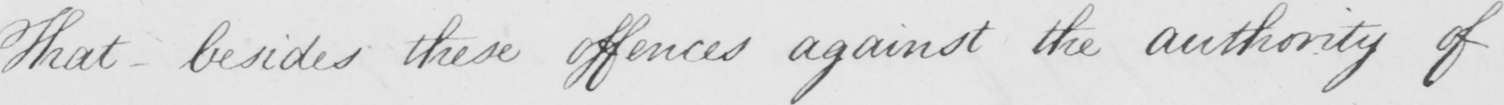Transcribe the text shown in this historical manuscript line. That besides these offences against the authority of 